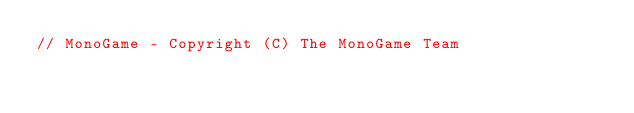Convert code to text. <code><loc_0><loc_0><loc_500><loc_500><_C#_>// MonoGame - Copyright (C) The MonoGame Team</code> 